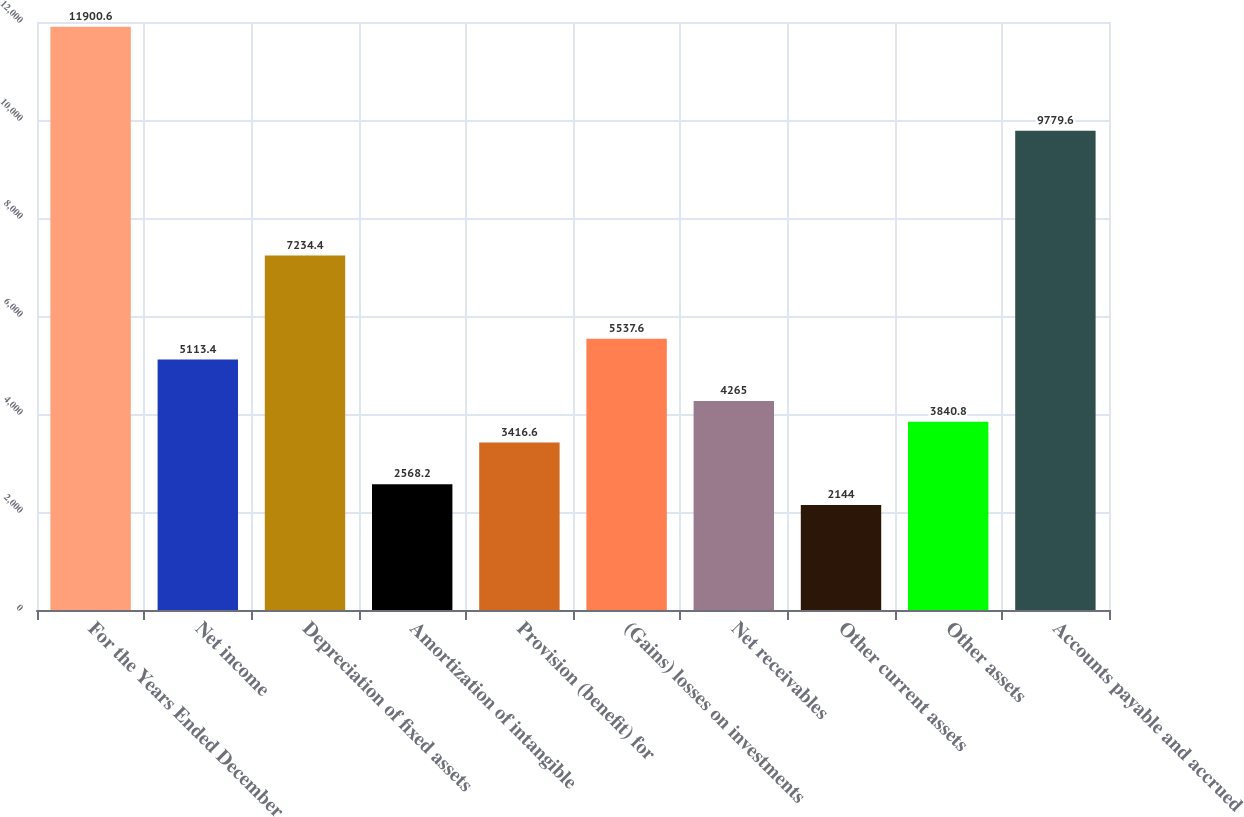<chart> <loc_0><loc_0><loc_500><loc_500><bar_chart><fcel>For the Years Ended December<fcel>Net income<fcel>Depreciation of fixed assets<fcel>Amortization of intangible<fcel>Provision (benefit) for<fcel>(Gains) losses on investments<fcel>Net receivables<fcel>Other current assets<fcel>Other assets<fcel>Accounts payable and accrued<nl><fcel>11900.6<fcel>5113.4<fcel>7234.4<fcel>2568.2<fcel>3416.6<fcel>5537.6<fcel>4265<fcel>2144<fcel>3840.8<fcel>9779.6<nl></chart> 